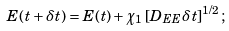Convert formula to latex. <formula><loc_0><loc_0><loc_500><loc_500>E ( t + \delta t ) = E ( t ) + \chi _ { 1 } \left [ D _ { E E } \delta t \right ] ^ { 1 / 2 } ;</formula> 